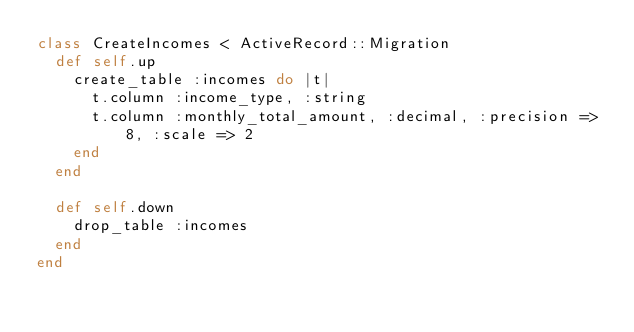Convert code to text. <code><loc_0><loc_0><loc_500><loc_500><_Ruby_>class CreateIncomes < ActiveRecord::Migration
  def self.up
    create_table :incomes do |t|
      t.column :income_type, :string
      t.column :monthly_total_amount, :decimal, :precision => 8, :scale => 2
    end
  end

  def self.down
    drop_table :incomes
  end
end
</code> 